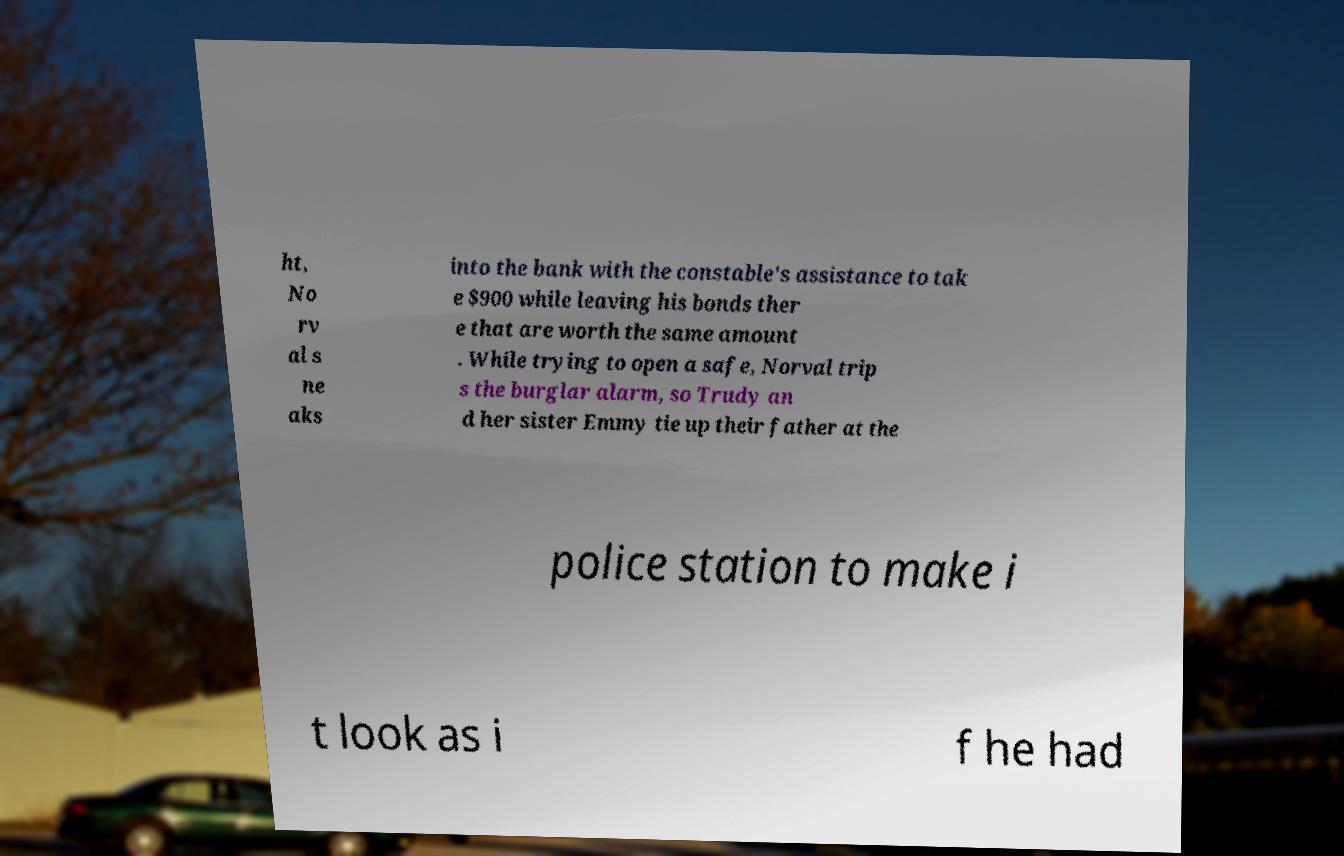There's text embedded in this image that I need extracted. Can you transcribe it verbatim? ht, No rv al s ne aks into the bank with the constable's assistance to tak e $900 while leaving his bonds ther e that are worth the same amount . While trying to open a safe, Norval trip s the burglar alarm, so Trudy an d her sister Emmy tie up their father at the police station to make i t look as i f he had 